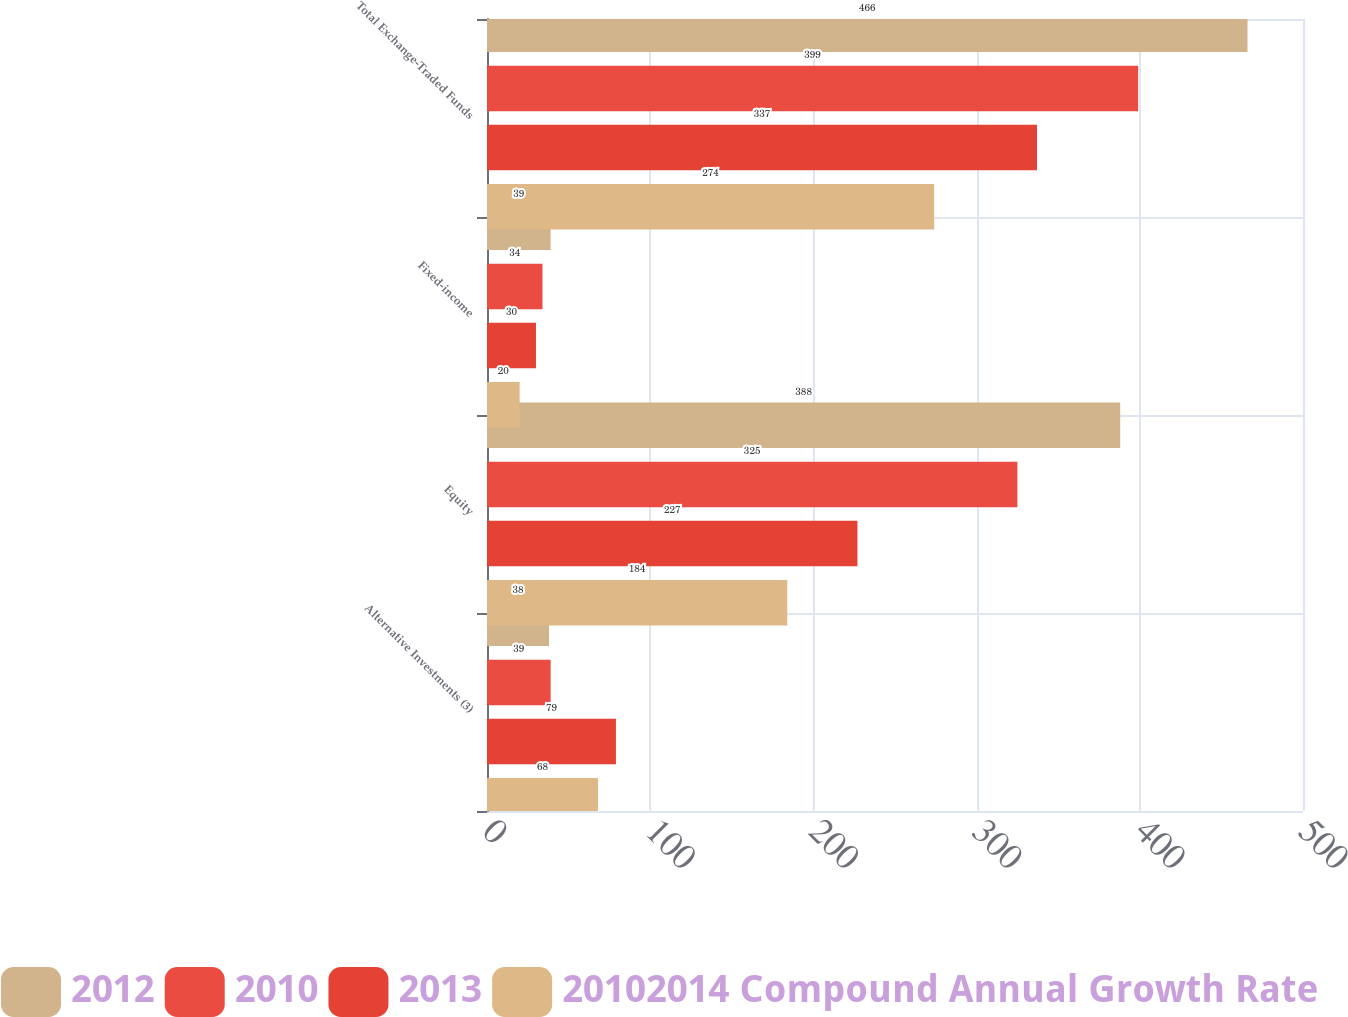<chart> <loc_0><loc_0><loc_500><loc_500><stacked_bar_chart><ecel><fcel>Alternative Investments (3)<fcel>Equity<fcel>Fixed-income<fcel>Total Exchange-Traded Funds<nl><fcel>2012<fcel>38<fcel>388<fcel>39<fcel>466<nl><fcel>2010<fcel>39<fcel>325<fcel>34<fcel>399<nl><fcel>2013<fcel>79<fcel>227<fcel>30<fcel>337<nl><fcel>20102014 Compound Annual Growth Rate<fcel>68<fcel>184<fcel>20<fcel>274<nl></chart> 